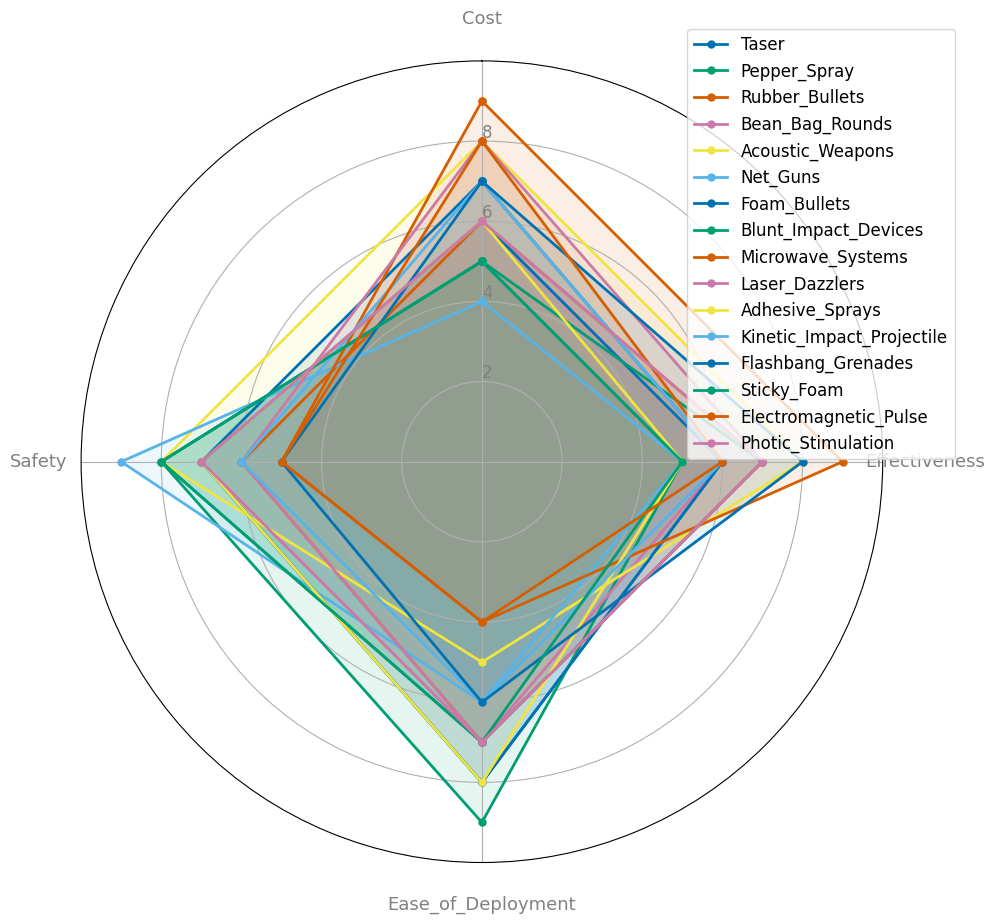Which non-lethal weapon technology has the highest effectiveness? By looking at the radar chart, identify the weapon with the point furthest from the center along the 'Effectiveness' axis.
Answer: Microwave Systems Which technology has the best combination of safety and ease of deployment? Find the technology with the highest summed scores on both 'Safety' and 'Ease of Deployment'. Mathematically, add those two scores for each technology and choose the highest.
Answer: Pepper Spray (17), Sticky Foam (15), Blunt Impact Devices (15), Adhesive Sprays (15), Foam Bullets (15), Taser (15) (Tie) Is Taser more cost-effective compared to Acoustic Weapons? Compare the 'Cost' and 'Effectiveness' values between Taser and Acoustic Weapons. Taser has a cost of 7 and effectiveness of 6, while Acoustic Weapons have a cost of 8 and effectiveness of 8.
Answer: No, Acoustic Weapons are more cost-effective with a higher effectiveness Which non-lethal weapon technology is the easiest to deploy? Identify the technology with the highest score on the 'Ease of Deployment' axis from the radar chart.
Answer: Pepper Spray What is the difference in safety scores between Microwave Systems and Net Guns? Find the 'Safety' values for Microwave Systems and Net Guns. For Microwave Systems, it is 5, and for Net Guns, it is 9. Subtract the safety score of Microwave Systems from Net Guns.
Answer: 4 higher for Net Guns Which technology ranks highest in both cost and safety? Identify the technology that scores the highest in both 'Cost' and 'Safety'. Microwave Systems score 9 in cost but only 5 in safety. Acoustic Weapons score 8 in safety but only 8 in cost.
Answer: Acoustic Weapons Are there any weapon technologies with equal scores for cost, effectiveness, ease of deployment, and safety? Check if any technology has the same numerical values across all four factors listed in the dataset or visualized on the radar chart.
Answer: No Which technology has a higher ease of deployment, Bean Bag Rounds or Kinetic Impact Projectile? Check the 'Ease of Deployment' scores for Bean Bag Rounds and Kinetic Impact Projectile on the radar chart. Bean Bag Rounds have a score of 7, while Kinetic Impact Projectile has a score of 6.
Answer: Bean Bag Rounds How does the safety of Laser Dazzlers compare to that of Flashbang Grenades? Compare the 'Safety' values of both Laser Dazzlers and Flashbang Grenades based on their positions on the 'Safety' axis. Laser Dazzlers have a score of 6, while Flashbang Grenades have a score of 5.
Answer: Laser Dazzlers is safer What is the average effectiveness score for all the technologies? Sum up all the effectiveness scores for each technology and divide by the total number of technologies. Specifically, add up the effectiveness scores (6 + 5 + 7 + 6 + 8 + 5 + 6 + 7 + 9 + 7 + 5 + 6 + 8 + 5 + 6 + 7) and divide by 16 (number of technologies).
Answer: 6.25 